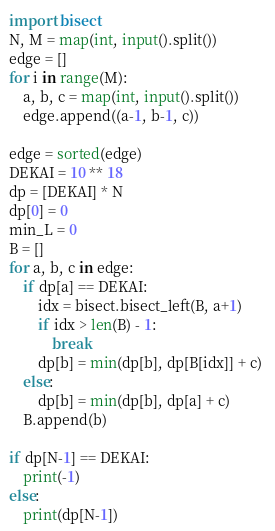<code> <loc_0><loc_0><loc_500><loc_500><_Python_>import bisect
N, M = map(int, input().split())
edge = []
for i in range(M):
    a, b, c = map(int, input().split())
    edge.append((a-1, b-1, c))

edge = sorted(edge)
DEKAI = 10 ** 18
dp = [DEKAI] * N
dp[0] = 0
min_L = 0
B = []
for a, b, c in edge:
    if dp[a] == DEKAI:
        idx = bisect.bisect_left(B, a+1)
        if idx > len(B) - 1:
            break
        dp[b] = min(dp[b], dp[B[idx]] + c) 
    else:
        dp[b] = min(dp[b], dp[a] + c)
    B.append(b)

if dp[N-1] == DEKAI:
    print(-1)
else:
    print(dp[N-1])

</code> 